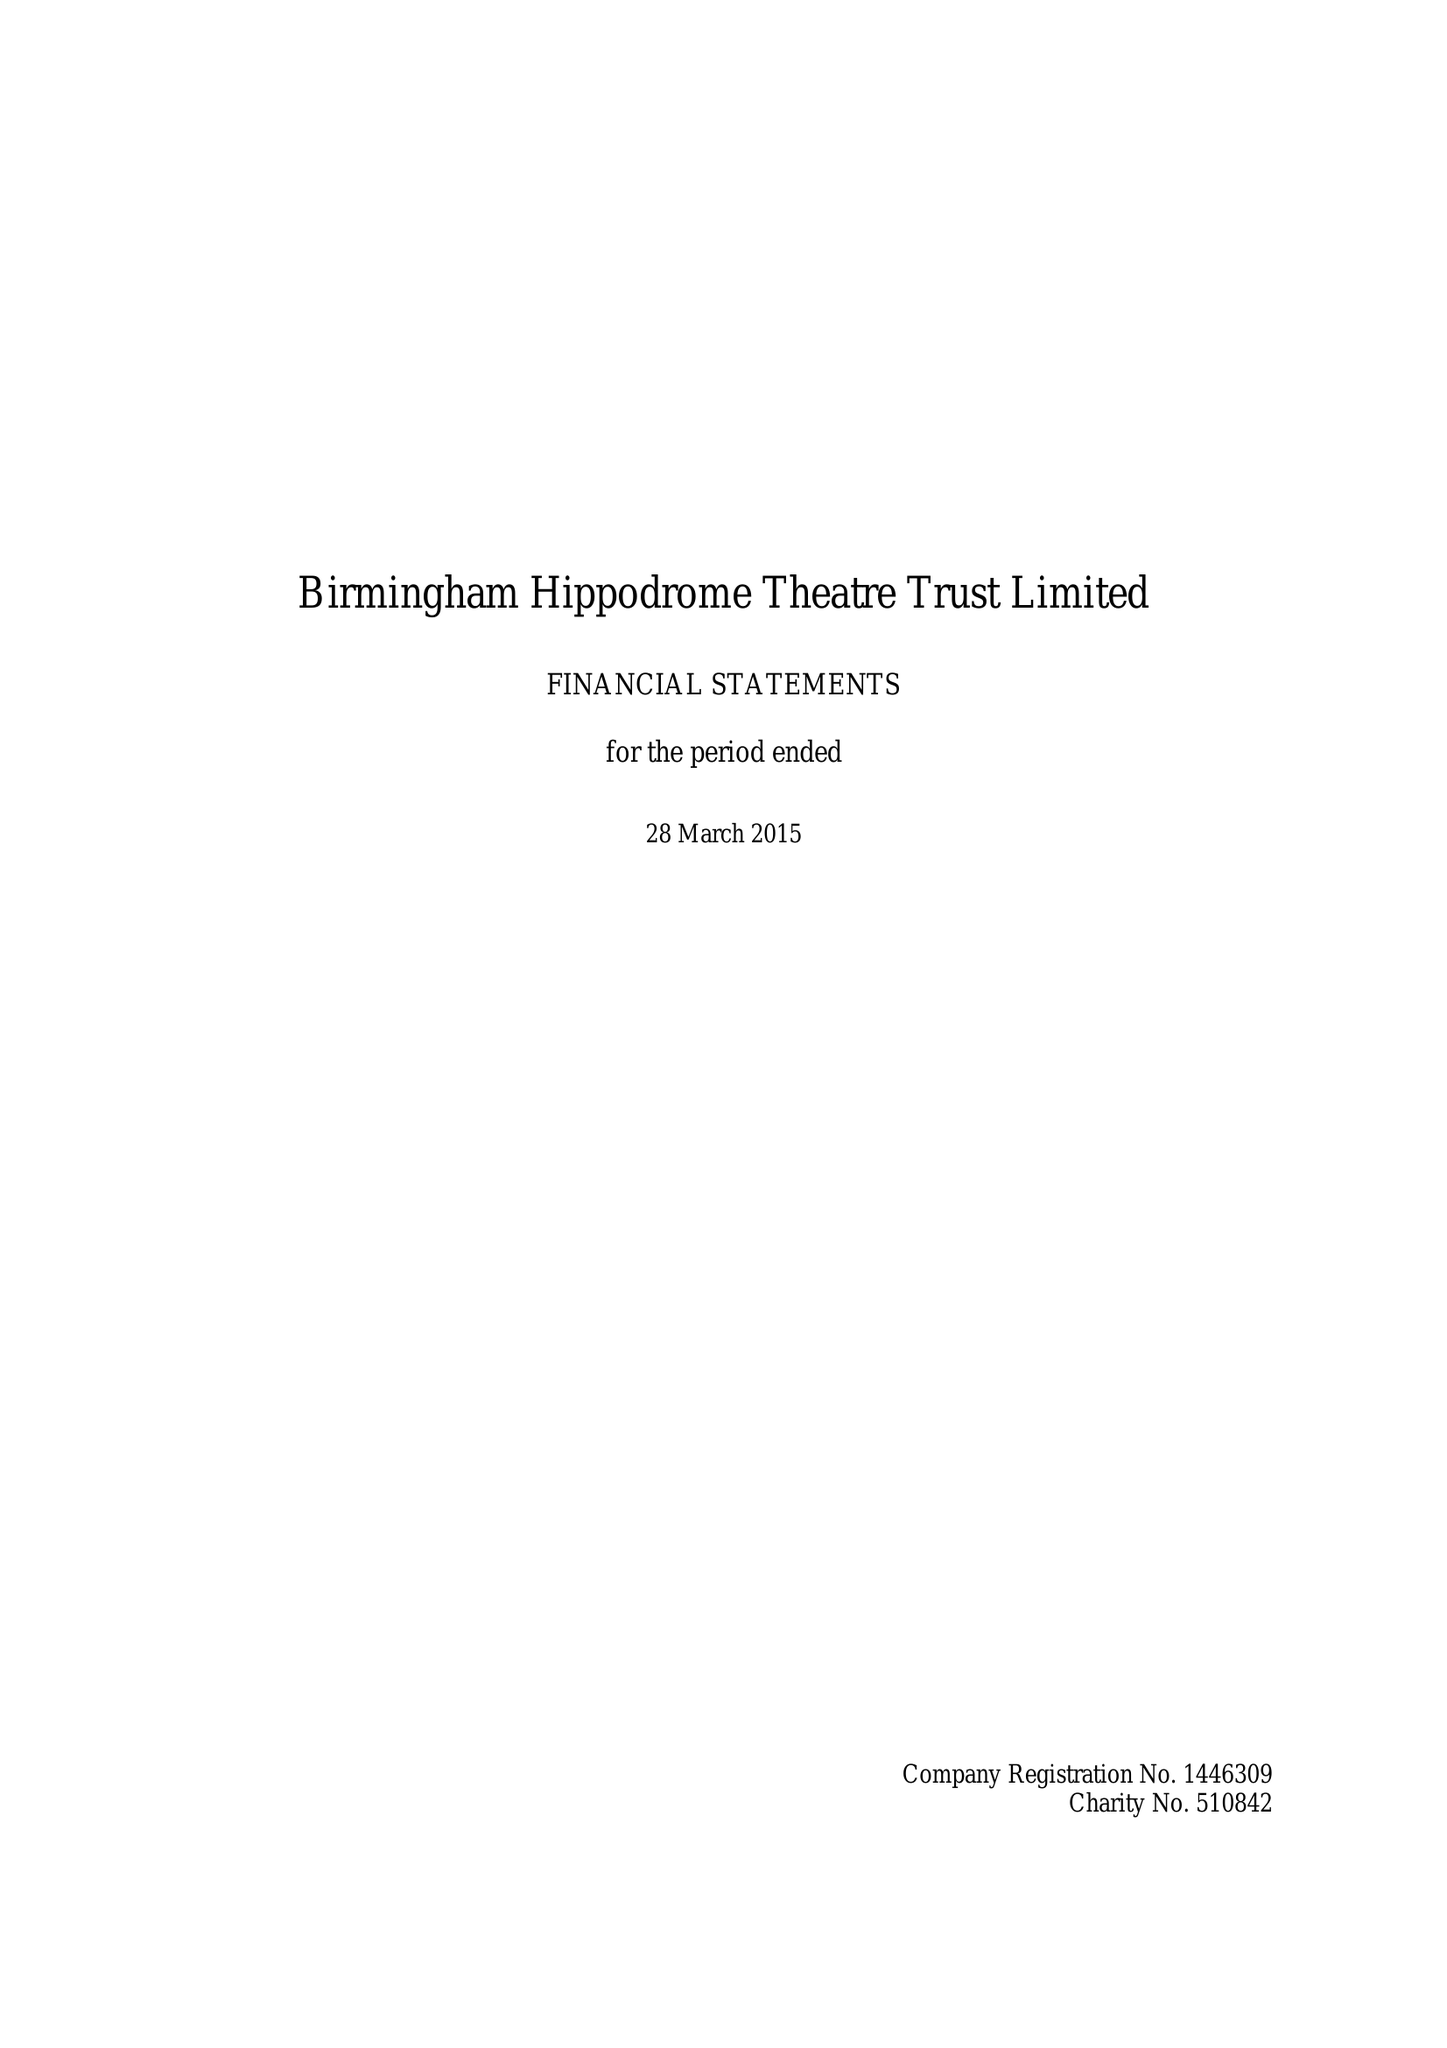What is the value for the charity_number?
Answer the question using a single word or phrase. 510842 